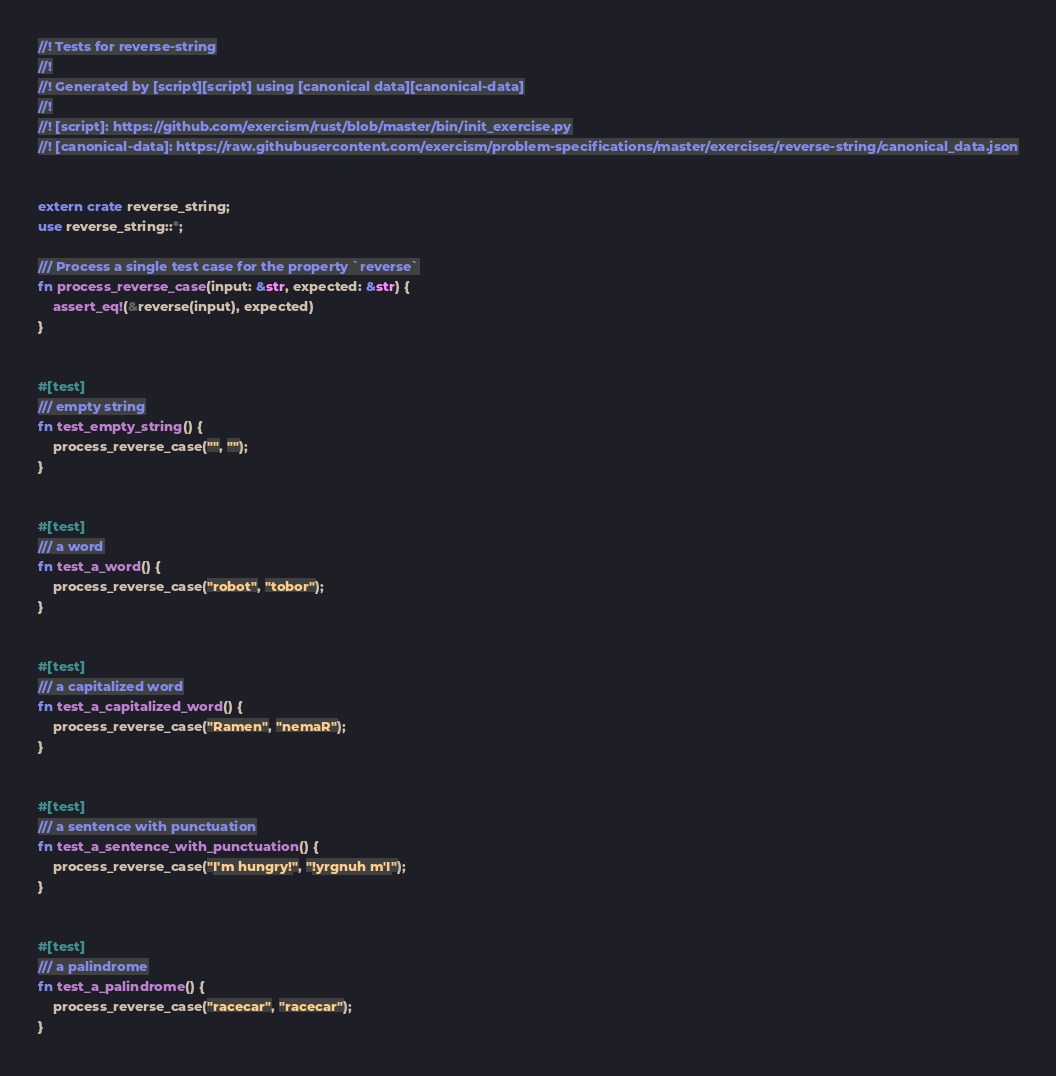<code> <loc_0><loc_0><loc_500><loc_500><_Rust_>//! Tests for reverse-string
//!
//! Generated by [script][script] using [canonical data][canonical-data]
//!
//! [script]: https://github.com/exercism/rust/blob/master/bin/init_exercise.py
//! [canonical-data]: https://raw.githubusercontent.com/exercism/problem-specifications/master/exercises/reverse-string/canonical_data.json


extern crate reverse_string;
use reverse_string::*;

/// Process a single test case for the property `reverse`
fn process_reverse_case(input: &str, expected: &str) {
    assert_eq!(&reverse(input), expected)
}


#[test]
/// empty string
fn test_empty_string() {
    process_reverse_case("", "");
}


#[test]
/// a word
fn test_a_word() {
    process_reverse_case("robot", "tobor");
}


#[test]
/// a capitalized word
fn test_a_capitalized_word() {
    process_reverse_case("Ramen", "nemaR");
}


#[test]
/// a sentence with punctuation
fn test_a_sentence_with_punctuation() {
    process_reverse_case("I'm hungry!", "!yrgnuh m'I");
}


#[test]
/// a palindrome
fn test_a_palindrome() {
    process_reverse_case("racecar", "racecar");
}
</code> 